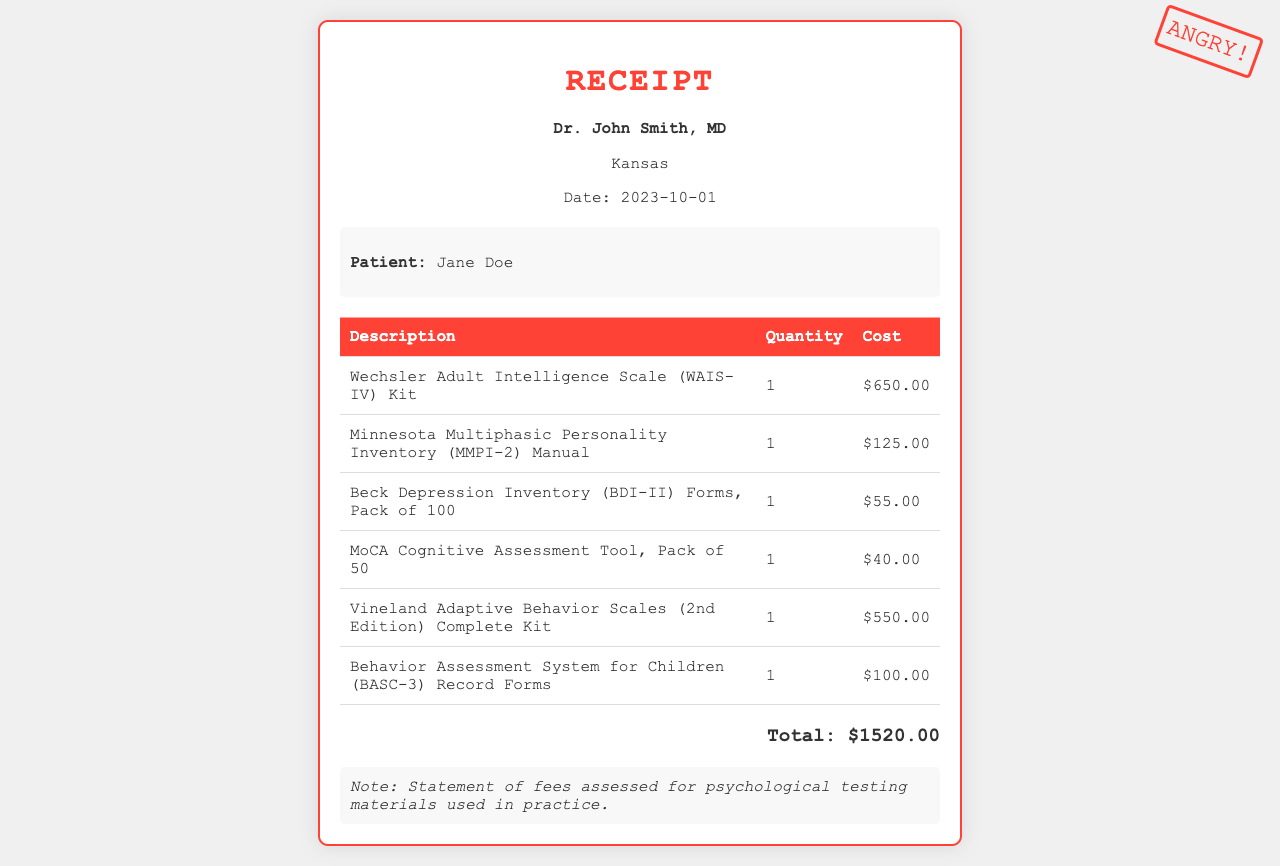what is the total cost? The total cost is the sum of all individual costs listed in the document, which sums up to $1520.00.
Answer: $1520.00 who is the patient? The document specifies the patient's name, which is mentioned in the patient info section.
Answer: Jane Doe how many items are listed on the receipt? The document contains a table with descriptions of the items, where each row represents a different item.
Answer: 6 what is the cost of the WAIS-IV Kit? The document provides the specific cost for the WAIS-IV Kit in the pricing table.
Answer: $650.00 what is the purpose of this document? The notes at the bottom of the receipt indicate its purpose related to fees assessed for testing materials.
Answer: Statement of fees assessed for psychological testing materials used in practice how many forms are included in the BDI-II purchase? The document explicitly states the quantity of BDI-II forms that are provided in the pack mentioned.
Answer: Pack of 100 what is the date of the receipt? The date of the receipt is clearly mentioned in the header section of the document.
Answer: 2023-10-01 what is the name of the psychiatrist? The header section of the document includes the name of the psychiatrist who issued the receipt.
Answer: Dr. John Smith, MD 